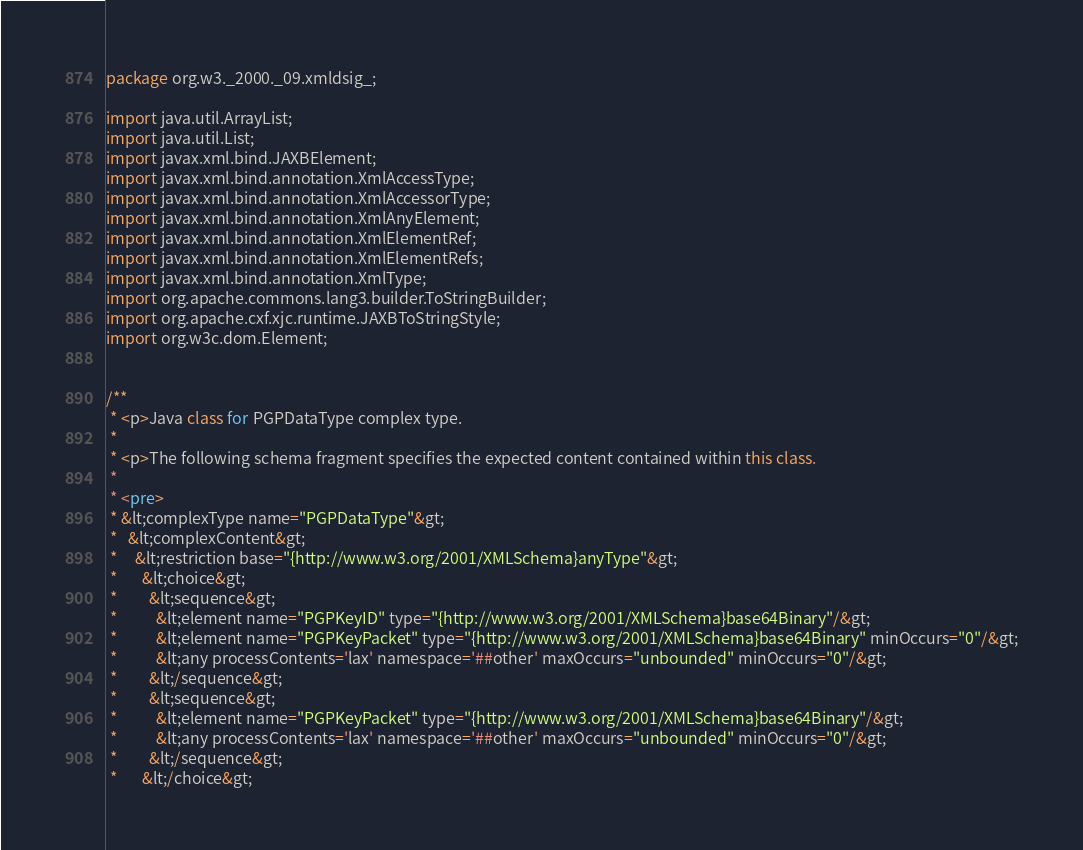<code> <loc_0><loc_0><loc_500><loc_500><_Java_>
package org.w3._2000._09.xmldsig_;

import java.util.ArrayList;
import java.util.List;
import javax.xml.bind.JAXBElement;
import javax.xml.bind.annotation.XmlAccessType;
import javax.xml.bind.annotation.XmlAccessorType;
import javax.xml.bind.annotation.XmlAnyElement;
import javax.xml.bind.annotation.XmlElementRef;
import javax.xml.bind.annotation.XmlElementRefs;
import javax.xml.bind.annotation.XmlType;
import org.apache.commons.lang3.builder.ToStringBuilder;
import org.apache.cxf.xjc.runtime.JAXBToStringStyle;
import org.w3c.dom.Element;


/**
 * <p>Java class for PGPDataType complex type.
 * 
 * <p>The following schema fragment specifies the expected content contained within this class.
 * 
 * <pre>
 * &lt;complexType name="PGPDataType"&gt;
 *   &lt;complexContent&gt;
 *     &lt;restriction base="{http://www.w3.org/2001/XMLSchema}anyType"&gt;
 *       &lt;choice&gt;
 *         &lt;sequence&gt;
 *           &lt;element name="PGPKeyID" type="{http://www.w3.org/2001/XMLSchema}base64Binary"/&gt;
 *           &lt;element name="PGPKeyPacket" type="{http://www.w3.org/2001/XMLSchema}base64Binary" minOccurs="0"/&gt;
 *           &lt;any processContents='lax' namespace='##other' maxOccurs="unbounded" minOccurs="0"/&gt;
 *         &lt;/sequence&gt;
 *         &lt;sequence&gt;
 *           &lt;element name="PGPKeyPacket" type="{http://www.w3.org/2001/XMLSchema}base64Binary"/&gt;
 *           &lt;any processContents='lax' namespace='##other' maxOccurs="unbounded" minOccurs="0"/&gt;
 *         &lt;/sequence&gt;
 *       &lt;/choice&gt;</code> 